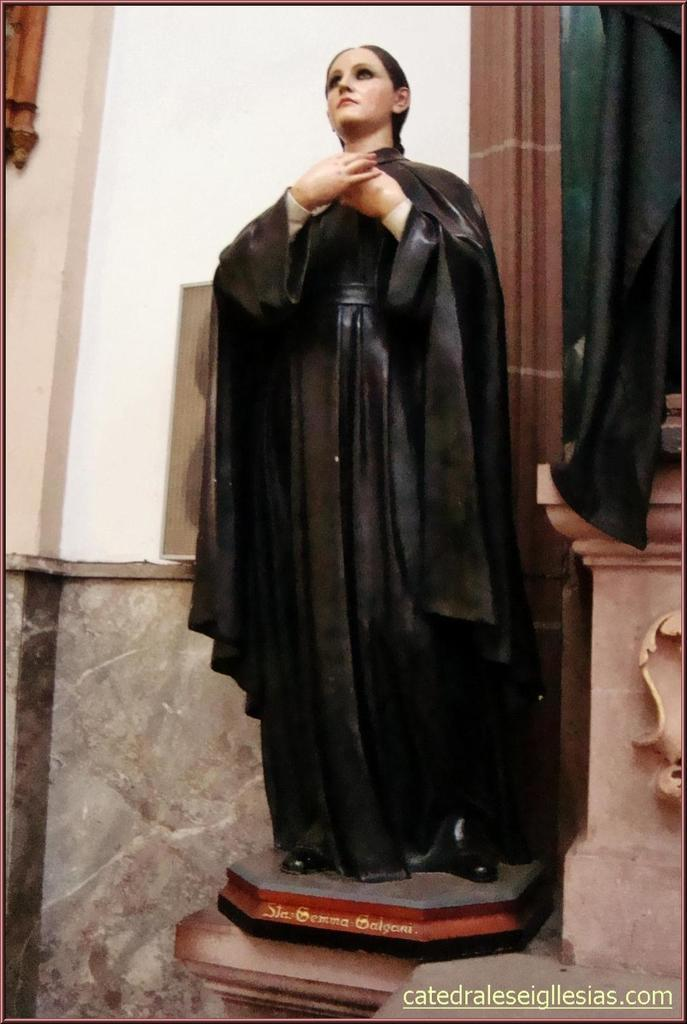What is the main subject of the image? There is a statue of a woman in the image. What is the woman wearing in the image? The woman is wearing a black dress in the image. What architectural features can be seen in the image? There is a wall and a pillar in the image. Is there any indication of the image's origin or ownership? Yes, there is a watermark on the image. How many brothers does the woman in the statue have in the image? There is no information about the woman's family or any brothers in the image. What type of key is used to unlock the statue in the image? There is no key or indication of the statue being locked in the image. 